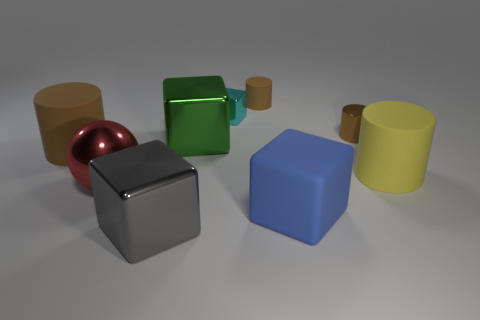Subtract all brown cylinders. How many were subtracted if there are1brown cylinders left? 2 Subtract all big cubes. How many cubes are left? 1 Subtract all brown cylinders. How many cylinders are left? 1 Subtract all spheres. How many objects are left? 8 Subtract all blue cubes. Subtract all blue cylinders. How many cubes are left? 3 Add 1 big red metal blocks. How many big red metal blocks exist? 1 Subtract 0 brown balls. How many objects are left? 9 Subtract 1 cylinders. How many cylinders are left? 3 Subtract all gray cylinders. How many cyan balls are left? 0 Subtract all small blocks. Subtract all large green metal blocks. How many objects are left? 7 